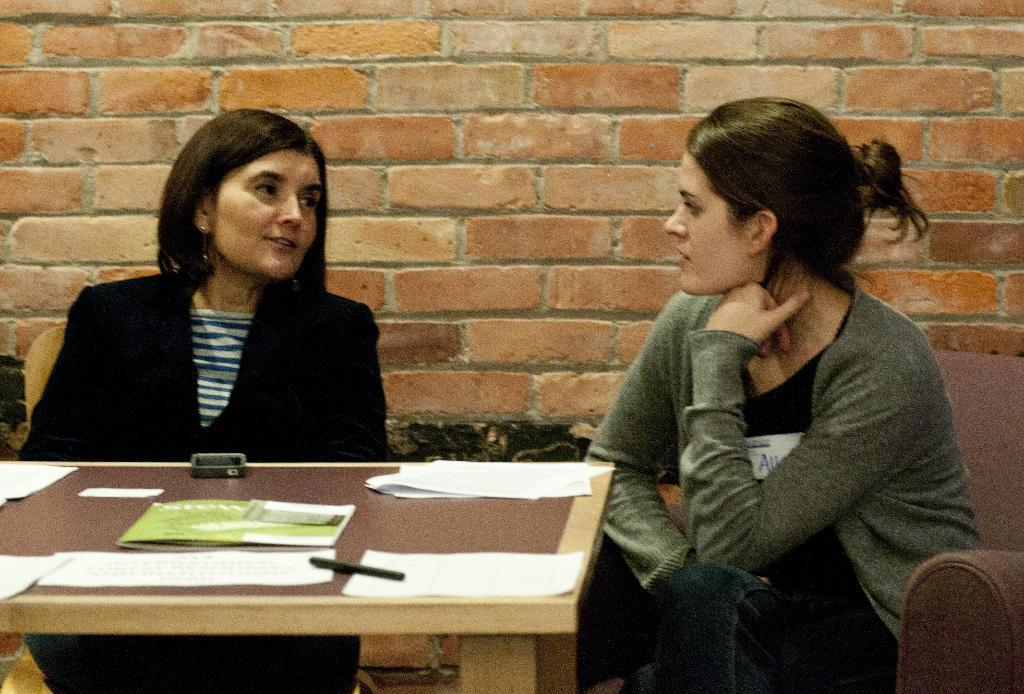What are the ladies wearing in the image? There is a lady wearing a sweater and another lady wearing a black coat in the image. How are the ladies positioned in relation to each other? The ladies are sitting beside each other in the image. What is on the table in front of the ladies? There are papers on a table in front of them, and there is also a pen on the table. What can be seen in the background of the image? There is a wall in the background of the image. What type of insurance policy are the ladies discussing in the image? There is no indication in the image that the ladies are discussing any insurance policies. 